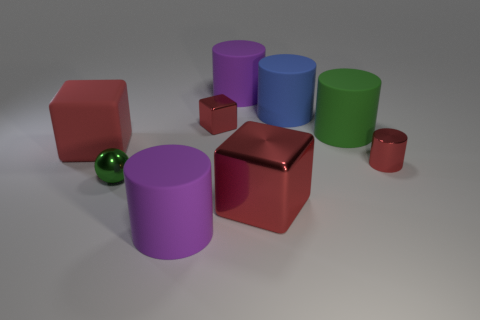What is the shape of the large object that is the same color as the large rubber cube?
Give a very brief answer. Cube. What material is the other large thing that is the same shape as the red rubber object?
Offer a terse response. Metal. Do the large green matte thing and the object in front of the big shiny thing have the same shape?
Your answer should be very brief. Yes. There is a block that is both in front of the big green rubber thing and on the right side of the big red rubber object; what color is it?
Give a very brief answer. Red. Is there a red object?
Ensure brevity in your answer.  Yes. Is the number of tiny balls behind the blue thing the same as the number of tiny metallic cylinders?
Your answer should be very brief. No. What number of other objects are there of the same shape as the green matte object?
Ensure brevity in your answer.  4. The green metal object is what shape?
Ensure brevity in your answer.  Sphere. Do the red cylinder and the blue cylinder have the same material?
Your answer should be compact. No. Are there an equal number of rubber cylinders behind the small red cylinder and large red blocks that are on the left side of the big red metal cube?
Your answer should be compact. No. 